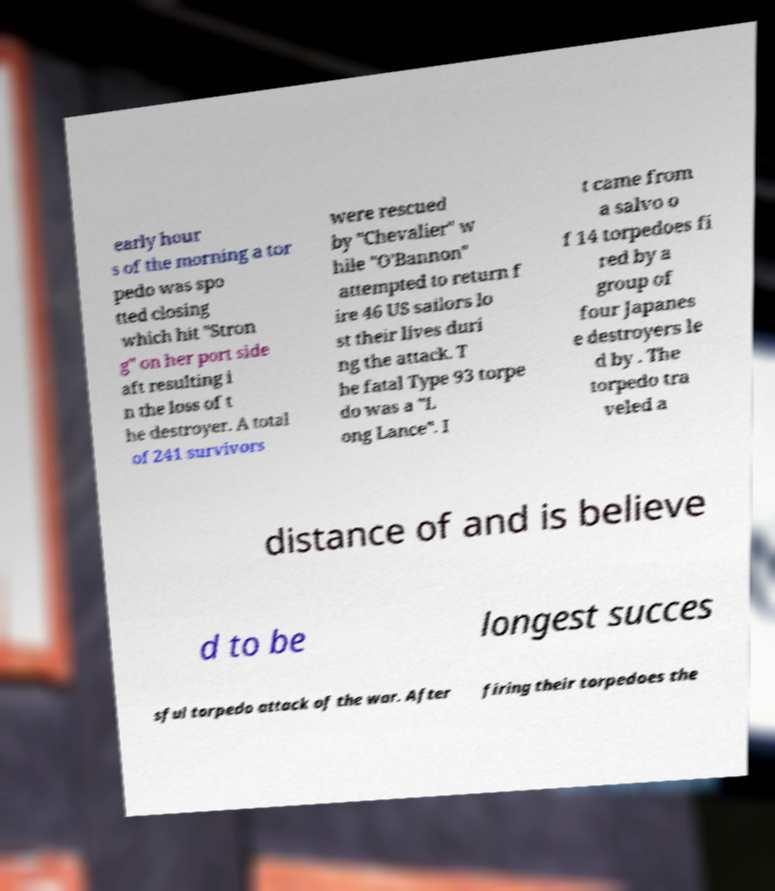There's text embedded in this image that I need extracted. Can you transcribe it verbatim? early hour s of the morning a tor pedo was spo tted closing which hit "Stron g" on her port side aft resulting i n the loss of t he destroyer. A total of 241 survivors were rescued by "Chevalier" w hile "O'Bannon" attempted to return f ire 46 US sailors lo st their lives duri ng the attack. T he fatal Type 93 torpe do was a "L ong Lance". I t came from a salvo o f 14 torpedoes fi red by a group of four Japanes e destroyers le d by . The torpedo tra veled a distance of and is believe d to be longest succes sful torpedo attack of the war. After firing their torpedoes the 